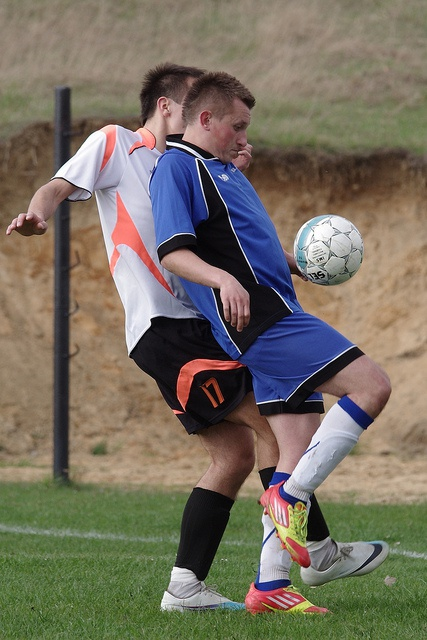Describe the objects in this image and their specific colors. I can see people in gray, black, blue, and navy tones, people in gray, black, lavender, and darkgray tones, and sports ball in gray, lightgray, darkgray, and lightblue tones in this image. 